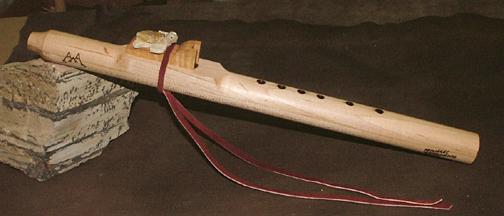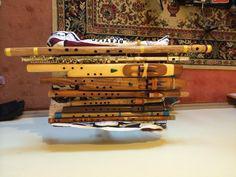The first image is the image on the left, the second image is the image on the right. Considering the images on both sides, is "IN at least one image there is a flute end sitting on a squarded rock." valid? Answer yes or no. Yes. The first image is the image on the left, the second image is the image on the right. Assess this claim about the two images: "An image shows a wooden flute with its mouthpiece end propped up and with a carved animal figure above a tassel tie.". Correct or not? Answer yes or no. Yes. 